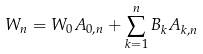<formula> <loc_0><loc_0><loc_500><loc_500>W _ { n } = W _ { 0 } A _ { 0 , n } + \sum _ { k = 1 } ^ { n } B _ { k } A _ { k , n }</formula> 